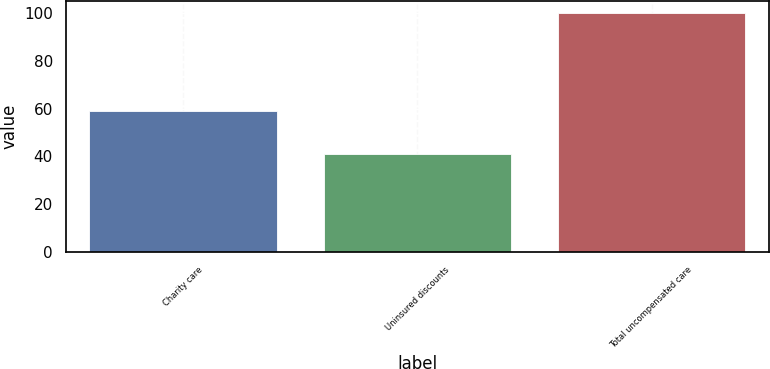Convert chart to OTSL. <chart><loc_0><loc_0><loc_500><loc_500><bar_chart><fcel>Charity care<fcel>Uninsured discounts<fcel>Total uncompensated care<nl><fcel>59<fcel>41<fcel>100<nl></chart> 